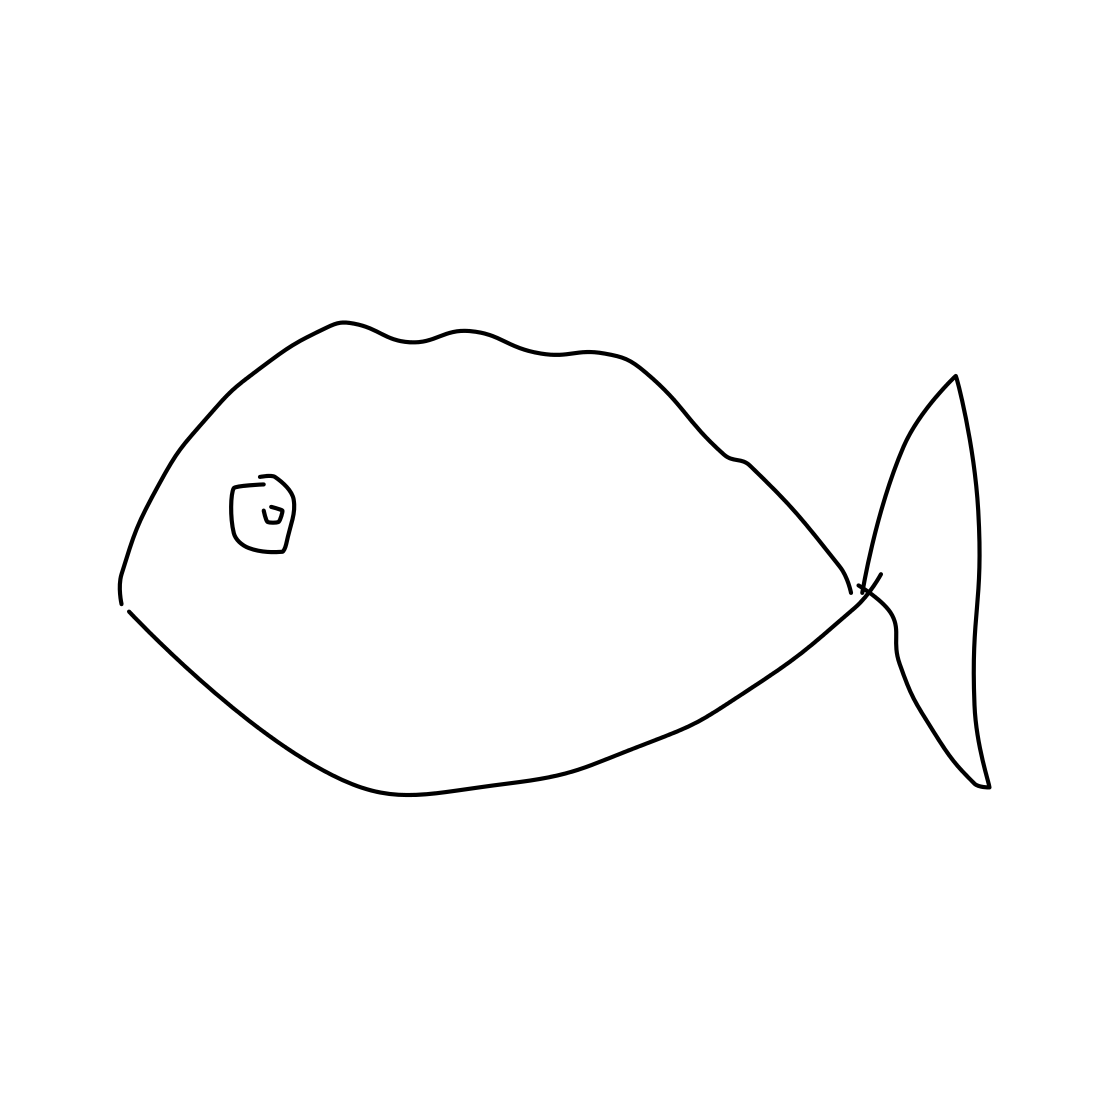Could this drawing symbolize something in a cultural context? The drawing could indeed have cultural symbolism. In many cultures, fish are seen as symbols of abundance and prosperity. The simplicity of the drawing may reflect a desire for a return to basics or an appreciation for the beauty found in simple forms. 